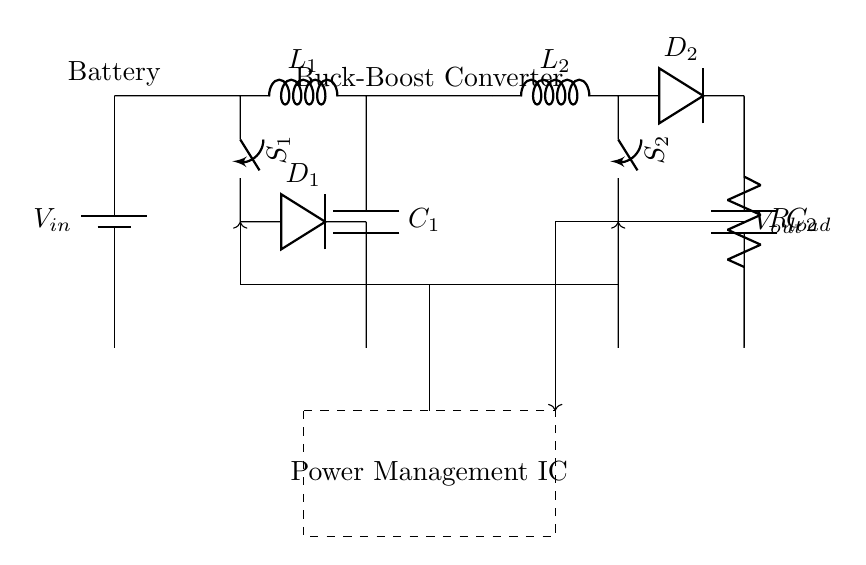What is the input voltage of the circuit? The input voltage is labeled as V sub in, which is represented by the battery symbol at the left side of the circuit.
Answer: V in What components are used in the buck converter section? The buck converter section consists of an inductor, a switch, a diode, and a capacitor, specifically labeled as L sub one, S sub one, D sub one, and C sub one.
Answer: Inductor, switch, diode, capacitor How many inductors are present in the circuit? There are two inductors identified in the diagram: L sub one in the buck converter and L sub two in the boost converter.
Answer: Two What does the dashed box represent in the circuit? The dashed box encloses the power management integrated circuit, indicating it controls the power distribution and management within the circuit.
Answer: Power Management IC Which component connects the load to the output? The component connecting the load (R sub load) to the output (V sub out) is the resistor, which is placed at the end of the circuit.
Answer: Resistor What is the function of the feedback connections depicted in the circuit? The feedback connections are used to convey the output voltage information back to the control block (power management IC), enabling it to adjust the input signals to maintain stable output.
Answer: Regulation 